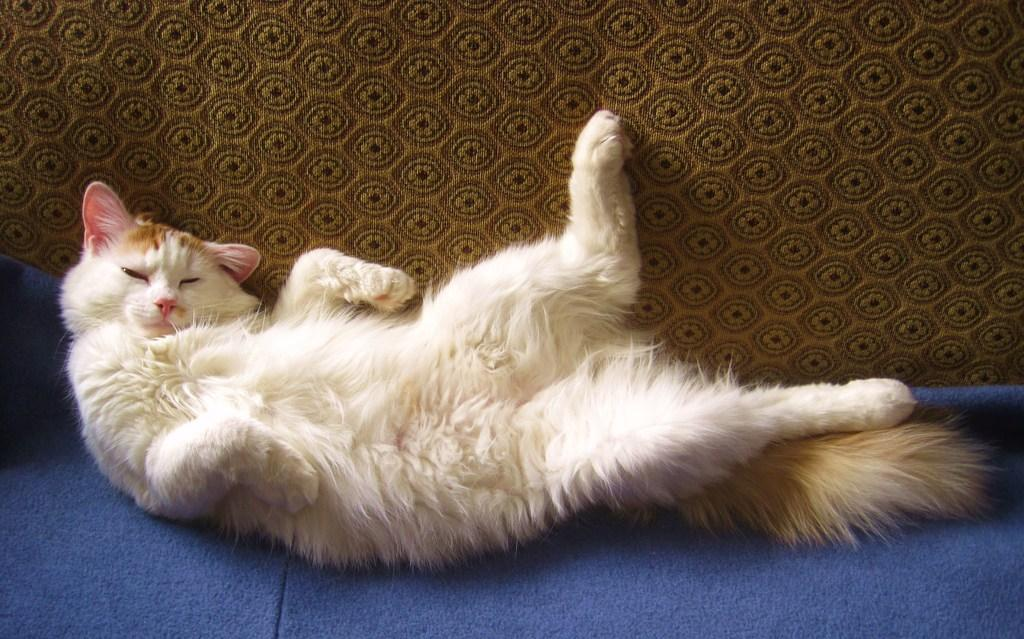What animal is the main subject of the image? There is a cat in the image. Where is the cat located in the image? The cat is in the center of the image. What surface is the cat on? The cat is on a carpet. What type of peace treaty is being signed by the cat in the image? There is no peace treaty or any indication of signing in the image; it simply features a cat in the center of the image on a carpet. 